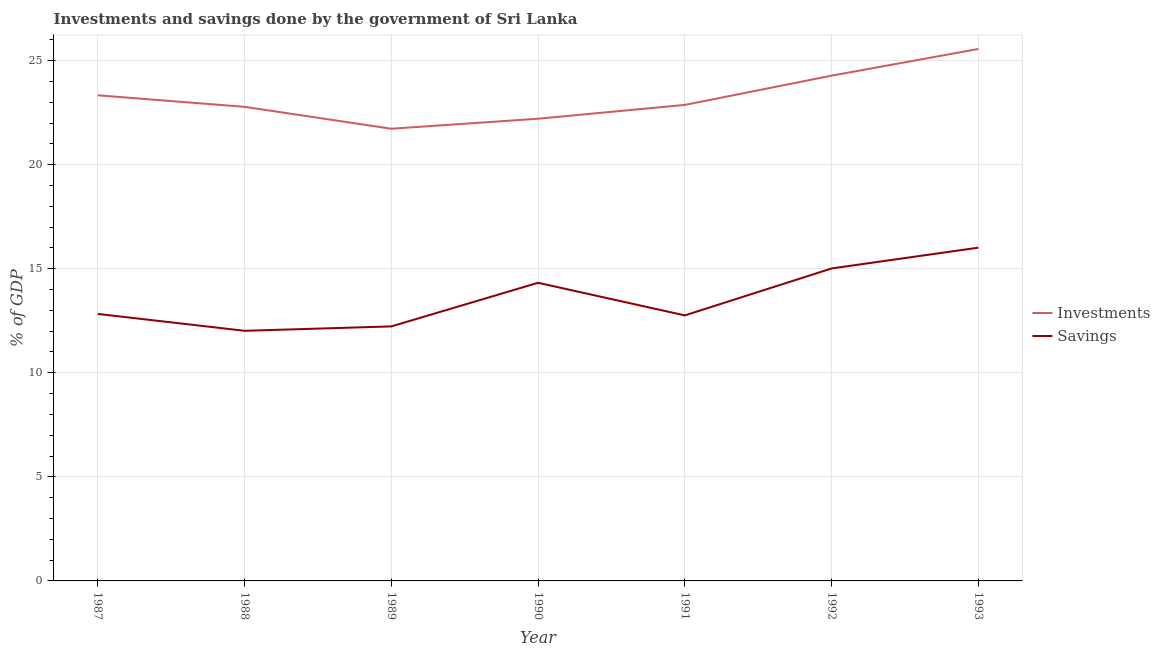Does the line corresponding to savings of government intersect with the line corresponding to investments of government?
Your answer should be compact. No. Is the number of lines equal to the number of legend labels?
Offer a terse response. Yes. What is the savings of government in 1988?
Offer a terse response. 12.02. Across all years, what is the maximum savings of government?
Give a very brief answer. 16.01. Across all years, what is the minimum savings of government?
Your answer should be compact. 12.02. In which year was the savings of government maximum?
Offer a terse response. 1993. What is the total savings of government in the graph?
Your response must be concise. 95.18. What is the difference between the savings of government in 1988 and that in 1992?
Offer a terse response. -3. What is the difference between the investments of government in 1991 and the savings of government in 1989?
Give a very brief answer. 10.64. What is the average investments of government per year?
Provide a succinct answer. 23.25. In the year 1990, what is the difference between the investments of government and savings of government?
Your answer should be compact. 7.88. In how many years, is the savings of government greater than 15 %?
Make the answer very short. 2. What is the ratio of the savings of government in 1988 to that in 1993?
Provide a short and direct response. 0.75. Is the savings of government in 1987 less than that in 1992?
Ensure brevity in your answer.  Yes. Is the difference between the investments of government in 1987 and 1989 greater than the difference between the savings of government in 1987 and 1989?
Offer a terse response. Yes. What is the difference between the highest and the second highest savings of government?
Your answer should be very brief. 1. What is the difference between the highest and the lowest savings of government?
Give a very brief answer. 3.99. In how many years, is the investments of government greater than the average investments of government taken over all years?
Keep it short and to the point. 3. Is the sum of the investments of government in 1990 and 1992 greater than the maximum savings of government across all years?
Provide a short and direct response. Yes. Does the savings of government monotonically increase over the years?
Offer a very short reply. No. Is the savings of government strictly greater than the investments of government over the years?
Keep it short and to the point. No. Is the savings of government strictly less than the investments of government over the years?
Your answer should be very brief. Yes. How many lines are there?
Offer a very short reply. 2. How many years are there in the graph?
Offer a terse response. 7. Does the graph contain any zero values?
Your response must be concise. No. Does the graph contain grids?
Give a very brief answer. Yes. What is the title of the graph?
Offer a very short reply. Investments and savings done by the government of Sri Lanka. What is the label or title of the X-axis?
Keep it short and to the point. Year. What is the label or title of the Y-axis?
Keep it short and to the point. % of GDP. What is the % of GDP of Investments in 1987?
Your response must be concise. 23.33. What is the % of GDP in Savings in 1987?
Provide a short and direct response. 12.83. What is the % of GDP of Investments in 1988?
Make the answer very short. 22.78. What is the % of GDP in Savings in 1988?
Make the answer very short. 12.02. What is the % of GDP in Investments in 1989?
Provide a short and direct response. 21.72. What is the % of GDP of Savings in 1989?
Your answer should be compact. 12.23. What is the % of GDP in Investments in 1990?
Offer a very short reply. 22.21. What is the % of GDP in Savings in 1990?
Your answer should be compact. 14.32. What is the % of GDP of Investments in 1991?
Your response must be concise. 22.87. What is the % of GDP of Savings in 1991?
Provide a short and direct response. 12.76. What is the % of GDP in Investments in 1992?
Provide a short and direct response. 24.28. What is the % of GDP in Savings in 1992?
Your answer should be very brief. 15.01. What is the % of GDP of Investments in 1993?
Your answer should be compact. 25.56. What is the % of GDP of Savings in 1993?
Your answer should be very brief. 16.01. Across all years, what is the maximum % of GDP in Investments?
Offer a terse response. 25.56. Across all years, what is the maximum % of GDP of Savings?
Your answer should be very brief. 16.01. Across all years, what is the minimum % of GDP of Investments?
Ensure brevity in your answer.  21.72. Across all years, what is the minimum % of GDP of Savings?
Your answer should be very brief. 12.02. What is the total % of GDP of Investments in the graph?
Your response must be concise. 162.74. What is the total % of GDP of Savings in the graph?
Your answer should be compact. 95.18. What is the difference between the % of GDP in Investments in 1987 and that in 1988?
Your answer should be very brief. 0.55. What is the difference between the % of GDP of Savings in 1987 and that in 1988?
Ensure brevity in your answer.  0.81. What is the difference between the % of GDP in Investments in 1987 and that in 1989?
Ensure brevity in your answer.  1.61. What is the difference between the % of GDP in Savings in 1987 and that in 1989?
Offer a very short reply. 0.6. What is the difference between the % of GDP in Investments in 1987 and that in 1990?
Offer a very short reply. 1.13. What is the difference between the % of GDP in Savings in 1987 and that in 1990?
Ensure brevity in your answer.  -1.5. What is the difference between the % of GDP in Investments in 1987 and that in 1991?
Your answer should be compact. 0.46. What is the difference between the % of GDP in Savings in 1987 and that in 1991?
Your response must be concise. 0.07. What is the difference between the % of GDP of Investments in 1987 and that in 1992?
Make the answer very short. -0.94. What is the difference between the % of GDP in Savings in 1987 and that in 1992?
Make the answer very short. -2.18. What is the difference between the % of GDP in Investments in 1987 and that in 1993?
Keep it short and to the point. -2.22. What is the difference between the % of GDP in Savings in 1987 and that in 1993?
Offer a terse response. -3.18. What is the difference between the % of GDP in Investments in 1988 and that in 1989?
Your answer should be compact. 1.05. What is the difference between the % of GDP of Savings in 1988 and that in 1989?
Ensure brevity in your answer.  -0.21. What is the difference between the % of GDP of Investments in 1988 and that in 1990?
Give a very brief answer. 0.57. What is the difference between the % of GDP in Savings in 1988 and that in 1990?
Give a very brief answer. -2.31. What is the difference between the % of GDP in Investments in 1988 and that in 1991?
Make the answer very short. -0.09. What is the difference between the % of GDP of Savings in 1988 and that in 1991?
Your answer should be very brief. -0.74. What is the difference between the % of GDP of Investments in 1988 and that in 1992?
Offer a terse response. -1.5. What is the difference between the % of GDP of Savings in 1988 and that in 1992?
Offer a very short reply. -3. What is the difference between the % of GDP of Investments in 1988 and that in 1993?
Offer a very short reply. -2.78. What is the difference between the % of GDP of Savings in 1988 and that in 1993?
Keep it short and to the point. -3.99. What is the difference between the % of GDP of Investments in 1989 and that in 1990?
Offer a very short reply. -0.48. What is the difference between the % of GDP in Savings in 1989 and that in 1990?
Provide a succinct answer. -2.1. What is the difference between the % of GDP in Investments in 1989 and that in 1991?
Offer a terse response. -1.15. What is the difference between the % of GDP of Savings in 1989 and that in 1991?
Provide a succinct answer. -0.53. What is the difference between the % of GDP of Investments in 1989 and that in 1992?
Offer a terse response. -2.55. What is the difference between the % of GDP in Savings in 1989 and that in 1992?
Provide a short and direct response. -2.78. What is the difference between the % of GDP in Investments in 1989 and that in 1993?
Your answer should be compact. -3.83. What is the difference between the % of GDP of Savings in 1989 and that in 1993?
Keep it short and to the point. -3.78. What is the difference between the % of GDP of Investments in 1990 and that in 1991?
Provide a short and direct response. -0.66. What is the difference between the % of GDP of Savings in 1990 and that in 1991?
Provide a succinct answer. 1.57. What is the difference between the % of GDP of Investments in 1990 and that in 1992?
Ensure brevity in your answer.  -2.07. What is the difference between the % of GDP of Savings in 1990 and that in 1992?
Offer a very short reply. -0.69. What is the difference between the % of GDP of Investments in 1990 and that in 1993?
Keep it short and to the point. -3.35. What is the difference between the % of GDP of Savings in 1990 and that in 1993?
Your response must be concise. -1.69. What is the difference between the % of GDP in Investments in 1991 and that in 1992?
Your answer should be compact. -1.41. What is the difference between the % of GDP of Savings in 1991 and that in 1992?
Keep it short and to the point. -2.26. What is the difference between the % of GDP in Investments in 1991 and that in 1993?
Your answer should be very brief. -2.69. What is the difference between the % of GDP of Savings in 1991 and that in 1993?
Keep it short and to the point. -3.26. What is the difference between the % of GDP in Investments in 1992 and that in 1993?
Keep it short and to the point. -1.28. What is the difference between the % of GDP in Savings in 1992 and that in 1993?
Your answer should be compact. -1. What is the difference between the % of GDP of Investments in 1987 and the % of GDP of Savings in 1988?
Offer a very short reply. 11.32. What is the difference between the % of GDP of Investments in 1987 and the % of GDP of Savings in 1989?
Your response must be concise. 11.1. What is the difference between the % of GDP in Investments in 1987 and the % of GDP in Savings in 1990?
Your response must be concise. 9.01. What is the difference between the % of GDP of Investments in 1987 and the % of GDP of Savings in 1991?
Make the answer very short. 10.58. What is the difference between the % of GDP in Investments in 1987 and the % of GDP in Savings in 1992?
Your answer should be compact. 8.32. What is the difference between the % of GDP in Investments in 1987 and the % of GDP in Savings in 1993?
Make the answer very short. 7.32. What is the difference between the % of GDP in Investments in 1988 and the % of GDP in Savings in 1989?
Ensure brevity in your answer.  10.55. What is the difference between the % of GDP of Investments in 1988 and the % of GDP of Savings in 1990?
Make the answer very short. 8.45. What is the difference between the % of GDP of Investments in 1988 and the % of GDP of Savings in 1991?
Provide a short and direct response. 10.02. What is the difference between the % of GDP of Investments in 1988 and the % of GDP of Savings in 1992?
Provide a succinct answer. 7.77. What is the difference between the % of GDP in Investments in 1988 and the % of GDP in Savings in 1993?
Provide a succinct answer. 6.77. What is the difference between the % of GDP in Investments in 1989 and the % of GDP in Savings in 1990?
Provide a succinct answer. 7.4. What is the difference between the % of GDP in Investments in 1989 and the % of GDP in Savings in 1991?
Give a very brief answer. 8.97. What is the difference between the % of GDP in Investments in 1989 and the % of GDP in Savings in 1992?
Your answer should be compact. 6.71. What is the difference between the % of GDP in Investments in 1989 and the % of GDP in Savings in 1993?
Ensure brevity in your answer.  5.71. What is the difference between the % of GDP in Investments in 1990 and the % of GDP in Savings in 1991?
Offer a very short reply. 9.45. What is the difference between the % of GDP of Investments in 1990 and the % of GDP of Savings in 1992?
Offer a very short reply. 7.19. What is the difference between the % of GDP in Investments in 1990 and the % of GDP in Savings in 1993?
Offer a terse response. 6.19. What is the difference between the % of GDP of Investments in 1991 and the % of GDP of Savings in 1992?
Give a very brief answer. 7.86. What is the difference between the % of GDP in Investments in 1991 and the % of GDP in Savings in 1993?
Your answer should be compact. 6.86. What is the difference between the % of GDP of Investments in 1992 and the % of GDP of Savings in 1993?
Make the answer very short. 8.26. What is the average % of GDP in Investments per year?
Your answer should be compact. 23.25. What is the average % of GDP of Savings per year?
Your answer should be compact. 13.6. In the year 1987, what is the difference between the % of GDP in Investments and % of GDP in Savings?
Ensure brevity in your answer.  10.5. In the year 1988, what is the difference between the % of GDP in Investments and % of GDP in Savings?
Ensure brevity in your answer.  10.76. In the year 1989, what is the difference between the % of GDP in Investments and % of GDP in Savings?
Offer a terse response. 9.5. In the year 1990, what is the difference between the % of GDP of Investments and % of GDP of Savings?
Make the answer very short. 7.88. In the year 1991, what is the difference between the % of GDP of Investments and % of GDP of Savings?
Make the answer very short. 10.11. In the year 1992, what is the difference between the % of GDP of Investments and % of GDP of Savings?
Your answer should be very brief. 9.26. In the year 1993, what is the difference between the % of GDP of Investments and % of GDP of Savings?
Ensure brevity in your answer.  9.55. What is the ratio of the % of GDP of Investments in 1987 to that in 1988?
Your answer should be compact. 1.02. What is the ratio of the % of GDP in Savings in 1987 to that in 1988?
Make the answer very short. 1.07. What is the ratio of the % of GDP of Investments in 1987 to that in 1989?
Your response must be concise. 1.07. What is the ratio of the % of GDP in Savings in 1987 to that in 1989?
Offer a very short reply. 1.05. What is the ratio of the % of GDP in Investments in 1987 to that in 1990?
Offer a terse response. 1.05. What is the ratio of the % of GDP in Savings in 1987 to that in 1990?
Ensure brevity in your answer.  0.9. What is the ratio of the % of GDP of Investments in 1987 to that in 1991?
Ensure brevity in your answer.  1.02. What is the ratio of the % of GDP in Savings in 1987 to that in 1991?
Offer a very short reply. 1.01. What is the ratio of the % of GDP in Investments in 1987 to that in 1992?
Keep it short and to the point. 0.96. What is the ratio of the % of GDP of Savings in 1987 to that in 1992?
Provide a short and direct response. 0.85. What is the ratio of the % of GDP in Investments in 1987 to that in 1993?
Your response must be concise. 0.91. What is the ratio of the % of GDP of Savings in 1987 to that in 1993?
Your answer should be very brief. 0.8. What is the ratio of the % of GDP of Investments in 1988 to that in 1989?
Offer a very short reply. 1.05. What is the ratio of the % of GDP in Savings in 1988 to that in 1989?
Your answer should be compact. 0.98. What is the ratio of the % of GDP in Investments in 1988 to that in 1990?
Your answer should be very brief. 1.03. What is the ratio of the % of GDP in Savings in 1988 to that in 1990?
Your response must be concise. 0.84. What is the ratio of the % of GDP in Savings in 1988 to that in 1991?
Your answer should be very brief. 0.94. What is the ratio of the % of GDP in Investments in 1988 to that in 1992?
Keep it short and to the point. 0.94. What is the ratio of the % of GDP of Savings in 1988 to that in 1992?
Keep it short and to the point. 0.8. What is the ratio of the % of GDP of Investments in 1988 to that in 1993?
Give a very brief answer. 0.89. What is the ratio of the % of GDP of Savings in 1988 to that in 1993?
Your answer should be compact. 0.75. What is the ratio of the % of GDP in Investments in 1989 to that in 1990?
Your response must be concise. 0.98. What is the ratio of the % of GDP in Savings in 1989 to that in 1990?
Make the answer very short. 0.85. What is the ratio of the % of GDP in Investments in 1989 to that in 1991?
Your answer should be compact. 0.95. What is the ratio of the % of GDP of Savings in 1989 to that in 1991?
Ensure brevity in your answer.  0.96. What is the ratio of the % of GDP in Investments in 1989 to that in 1992?
Provide a short and direct response. 0.89. What is the ratio of the % of GDP of Savings in 1989 to that in 1992?
Provide a succinct answer. 0.81. What is the ratio of the % of GDP of Savings in 1989 to that in 1993?
Offer a terse response. 0.76. What is the ratio of the % of GDP of Savings in 1990 to that in 1991?
Make the answer very short. 1.12. What is the ratio of the % of GDP in Investments in 1990 to that in 1992?
Keep it short and to the point. 0.91. What is the ratio of the % of GDP of Savings in 1990 to that in 1992?
Provide a short and direct response. 0.95. What is the ratio of the % of GDP of Investments in 1990 to that in 1993?
Give a very brief answer. 0.87. What is the ratio of the % of GDP of Savings in 1990 to that in 1993?
Your answer should be very brief. 0.89. What is the ratio of the % of GDP of Investments in 1991 to that in 1992?
Ensure brevity in your answer.  0.94. What is the ratio of the % of GDP in Savings in 1991 to that in 1992?
Offer a terse response. 0.85. What is the ratio of the % of GDP in Investments in 1991 to that in 1993?
Provide a succinct answer. 0.89. What is the ratio of the % of GDP in Savings in 1991 to that in 1993?
Give a very brief answer. 0.8. What is the ratio of the % of GDP in Investments in 1992 to that in 1993?
Your answer should be compact. 0.95. What is the ratio of the % of GDP of Savings in 1992 to that in 1993?
Your answer should be very brief. 0.94. What is the difference between the highest and the second highest % of GDP in Investments?
Offer a terse response. 1.28. What is the difference between the highest and the second highest % of GDP of Savings?
Your answer should be very brief. 1. What is the difference between the highest and the lowest % of GDP in Investments?
Keep it short and to the point. 3.83. What is the difference between the highest and the lowest % of GDP of Savings?
Offer a terse response. 3.99. 